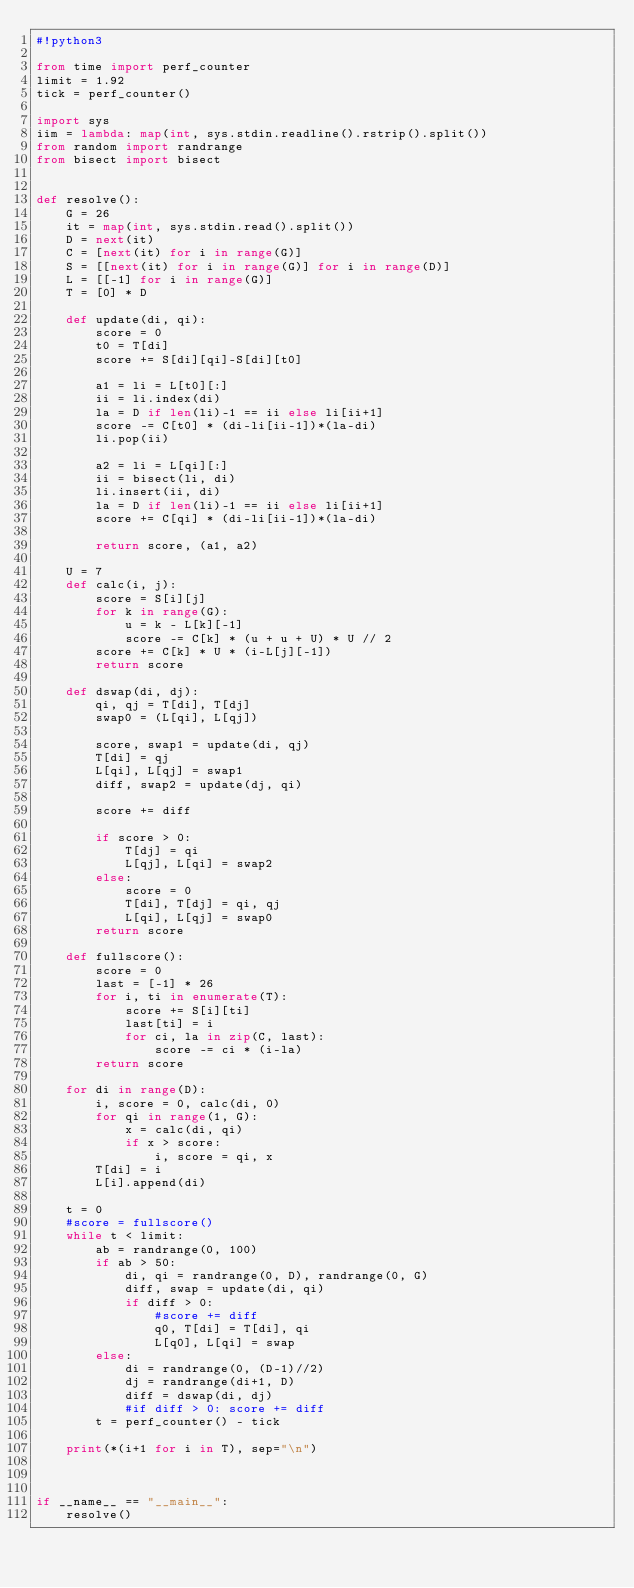<code> <loc_0><loc_0><loc_500><loc_500><_Python_>#!python3

from time import perf_counter
limit = 1.92
tick = perf_counter()

import sys
iim = lambda: map(int, sys.stdin.readline().rstrip().split())
from random import randrange
from bisect import bisect


def resolve():
    G = 26
    it = map(int, sys.stdin.read().split())
    D = next(it)
    C = [next(it) for i in range(G)]
    S = [[next(it) for i in range(G)] for i in range(D)]
    L = [[-1] for i in range(G)]
    T = [0] * D

    def update(di, qi):
        score = 0
        t0 = T[di]
        score += S[di][qi]-S[di][t0]

        a1 = li = L[t0][:]
        ii = li.index(di)
        la = D if len(li)-1 == ii else li[ii+1]
        score -= C[t0] * (di-li[ii-1])*(la-di)
        li.pop(ii)

        a2 = li = L[qi][:]
        ii = bisect(li, di)
        li.insert(ii, di)
        la = D if len(li)-1 == ii else li[ii+1]
        score += C[qi] * (di-li[ii-1])*(la-di)

        return score, (a1, a2)

    U = 7
    def calc(i, j):
        score = S[i][j]
        for k in range(G):
            u = k - L[k][-1]
            score -= C[k] * (u + u + U) * U // 2
        score += C[k] * U * (i-L[j][-1])
        return score

    def dswap(di, dj):
        qi, qj = T[di], T[dj]
        swap0 = (L[qi], L[qj])

        score, swap1 = update(di, qj)
        T[di] = qj
        L[qi], L[qj] = swap1
        diff, swap2 = update(dj, qi)

        score += diff

        if score > 0:
            T[dj] = qi
            L[qj], L[qi] = swap2
        else:
            score = 0
            T[di], T[dj] = qi, qj
            L[qi], L[qj] = swap0
        return score

    def fullscore():
        score = 0
        last = [-1] * 26
        for i, ti in enumerate(T):
            score += S[i][ti]
            last[ti] = i
            for ci, la in zip(C, last):
                score -= ci * (i-la)
        return score

    for di in range(D):
        i, score = 0, calc(di, 0)
        for qi in range(1, G):
            x = calc(di, qi)
            if x > score:
                i, score = qi, x
        T[di] = i
        L[i].append(di)

    t = 0
    #score = fullscore()
    while t < limit:
        ab = randrange(0, 100)
        if ab > 50:
            di, qi = randrange(0, D), randrange(0, G)
            diff, swap = update(di, qi)
            if diff > 0:
                #score += diff
                q0, T[di] = T[di], qi
                L[q0], L[qi] = swap
        else:
            di = randrange(0, (D-1)//2)
            dj = randrange(di+1, D)
            diff = dswap(di, dj)
            #if diff > 0: score += diff
        t = perf_counter() - tick

    print(*(i+1 for i in T), sep="\n")



if __name__ == "__main__":
    resolve()
</code> 